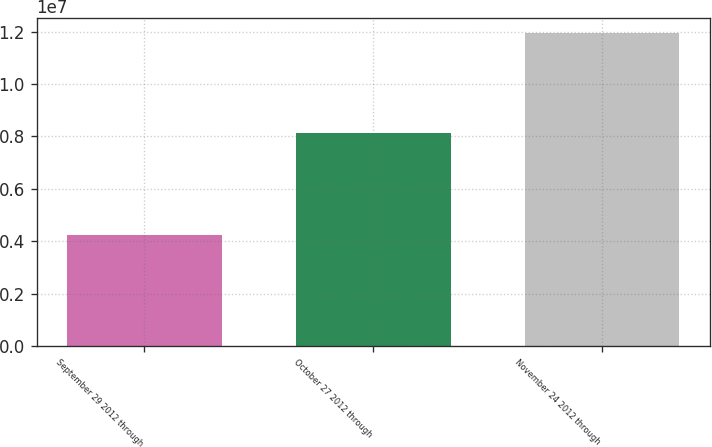Convert chart to OTSL. <chart><loc_0><loc_0><loc_500><loc_500><bar_chart><fcel>September 29 2012 through<fcel>October 27 2012 through<fcel>November 24 2012 through<nl><fcel>4.24e+06<fcel>8.1341e+06<fcel>1.19309e+07<nl></chart> 